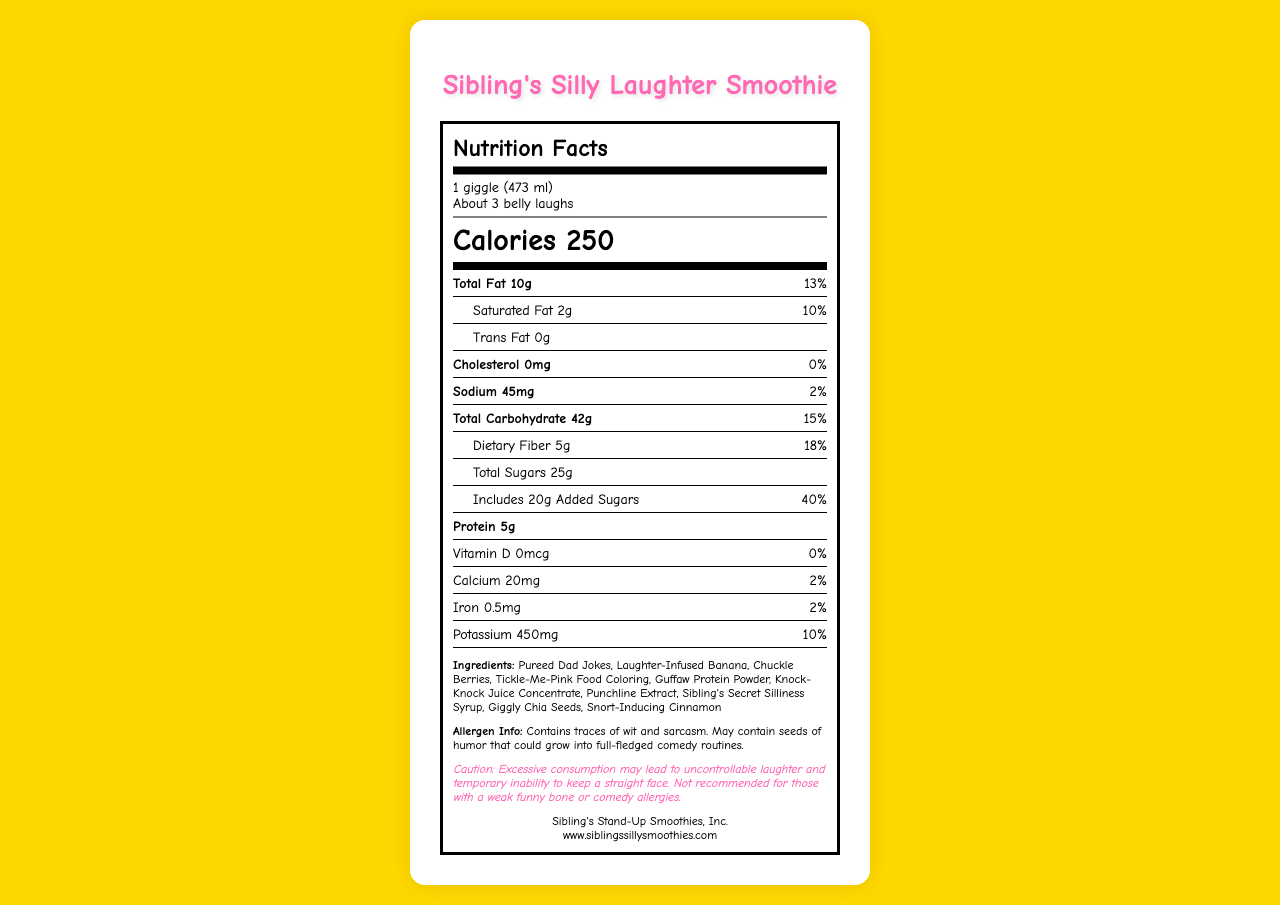what is the serving size for the Sibling's Silly Laughter Smoothie? The serving size is mentioned at the top of the Nutrition Facts label as "1 giggle (473 ml)".
Answer: 1 giggle (473 ml) how many servings are in one container? The servings per container are listed right below the serving size and state "About 3 belly laughs".
Answer: About 3 belly laughs how many calories does one serving of the Laughter Smoothie contain? The calorie content for one serving is prominently displayed in the central part of the Nutrition Facts label as "250".
Answer: 250 what is the total fat content per serving? The total fat content is listed under the Nutrients section as "Total Fat 10g".
Answer: 10g what percentage of the daily value is the saturated fat per serving? Right below the total fat content, the saturated fat is listed as "2g" with the daily value percentage of "10%".
Answer: 10% what ingredient adds a humorous twist to this smoothie? A. Pureed Dad Jokes B. Vanilla Extract C. Cocoa Powder The ingredients list includes "Pureed Dad Jokes," which is humorously fitting for a laughter smoothie.
Answer: A how many grams of added sugars are included per serving? 1. 10g 2. 15g 3. 20g 4. 25g The section under Total Carbohydrate specifies "Includes 20g Added Sugars" as part of "Total Sugars 25g."
Answer: 3 is there any cholesterol in the Laughter Smoothie? The cholesterol is listed as "0mg" with a daily value of "0%" indicating there is no cholesterol in one serving of the Smoothie.
Answer: No what is the main idea of the document? The document includes typical nutritional facts like calories, fat content, and vitamins, alongside humorous descriptions and ingredients to add a comedic touch.
Answer: The main idea of the document is to provide the nutritional information for Sibling's Silly Laughter Smoothie, presented in a humorous and exaggerated manner to match the comical nature of the product. what is the vitamin D content for the Sibling's Silly Laughter Smoothie? The vitamin D content is listed under the Nutrient Facts as "Vitamin D 0mcg".
Answer: 0mcg does the document indicate that the Laughter Smoothie contains dangerous allergens? The allergen information humorously mentions "traces of wit and sarcasm" rather than any dangerous allergens.
Answer: No what website can you visit for more information on Sibling's Silly Laughter Smoothies? At the bottom of the label, the website is noted as "www.siblingssillysmoothies.com".
Answer: www.siblingssillysmoothies.com what is the warning given in the disclaimer? The disclaimer humorously warns about laughter and the inability to keep a straight face due to excessive consumption.
Answer: Excessive consumption may lead to uncontrollable laughter and temporary inability to keep a straight face. which nutrient has the highest daily value percentage per serving? A. Total Fat B. Dietary Fiber C. Added Sugars The highest percentage is "Added Sugars" with "40%", compared to Total Fat (13%) and Dietary Fiber (18%).
Answer: C how many grams of protein are in each serving? The amount of protein per serving is listed as "5g".
Answer: 5g who is the manufacturer of the Laughter Smoothie? The manufacturer information is at the bottom of the label, "Sibling's Stand-Up Smoothies, Inc.".
Answer: Sibling's Stand-Up Smoothies, Inc. what are the colors used in the document? The text of the document does not specify the colors used in the visual presentation, only typical nutritional data and humorous content.
Answer: Not enough information 